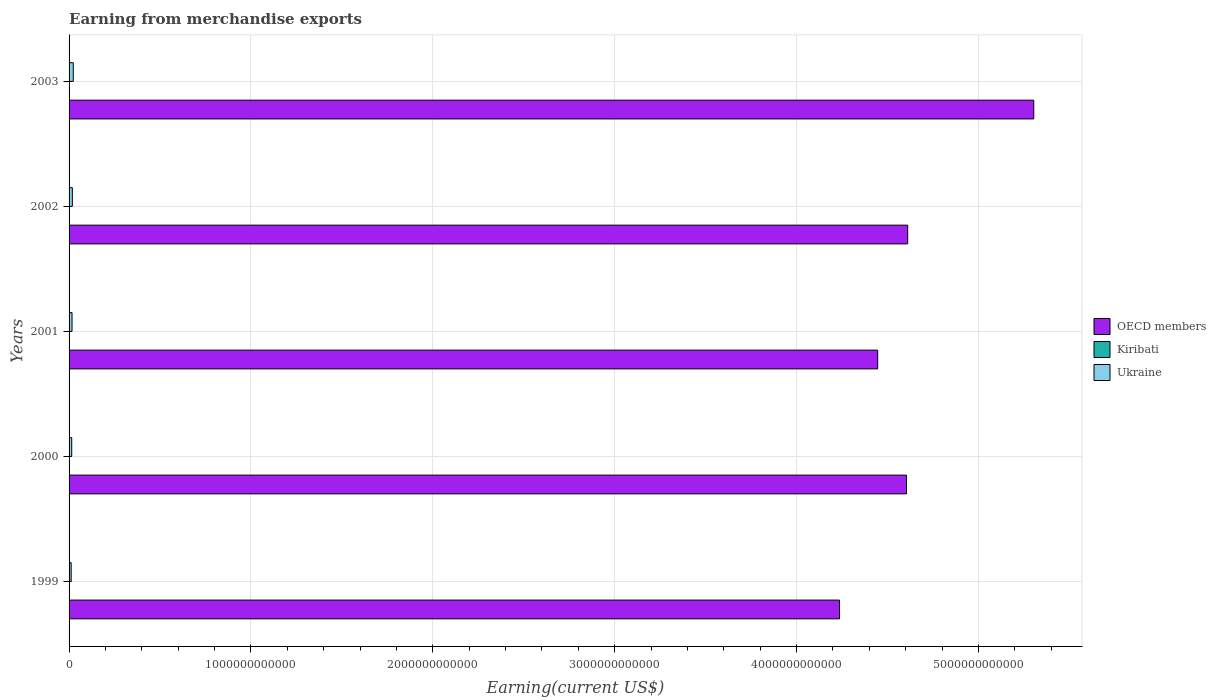How many different coloured bars are there?
Provide a short and direct response. 3. Are the number of bars per tick equal to the number of legend labels?
Give a very brief answer. Yes. How many bars are there on the 2nd tick from the top?
Offer a very short reply. 3. What is the amount earned from merchandise exports in Kiribati in 2002?
Your answer should be very brief. 3.44e+06. Across all years, what is the maximum amount earned from merchandise exports in Kiribati?
Provide a short and direct response. 8.76e+06. Across all years, what is the minimum amount earned from merchandise exports in Kiribati?
Your answer should be very brief. 2.90e+06. In which year was the amount earned from merchandise exports in OECD members maximum?
Ensure brevity in your answer.  2003. What is the total amount earned from merchandise exports in Ukraine in the graph?
Give a very brief answer. 8.34e+1. What is the difference between the amount earned from merchandise exports in Kiribati in 2000 and that in 2001?
Provide a short and direct response. -9.25e+05. What is the difference between the amount earned from merchandise exports in OECD members in 2001 and the amount earned from merchandise exports in Ukraine in 2002?
Your answer should be compact. 4.43e+12. What is the average amount earned from merchandise exports in Kiribati per year?
Offer a terse response. 4.64e+06. In the year 2001, what is the difference between the amount earned from merchandise exports in Kiribati and amount earned from merchandise exports in OECD members?
Offer a terse response. -4.45e+12. In how many years, is the amount earned from merchandise exports in Kiribati greater than 2800000000000 US$?
Your answer should be very brief. 0. What is the ratio of the amount earned from merchandise exports in OECD members in 1999 to that in 2002?
Provide a short and direct response. 0.92. Is the amount earned from merchandise exports in OECD members in 2000 less than that in 2002?
Offer a terse response. Yes. What is the difference between the highest and the second highest amount earned from merchandise exports in OECD members?
Ensure brevity in your answer.  6.93e+11. What is the difference between the highest and the lowest amount earned from merchandise exports in Kiribati?
Ensure brevity in your answer.  5.86e+06. What does the 1st bar from the bottom in 1999 represents?
Keep it short and to the point. OECD members. How many years are there in the graph?
Offer a very short reply. 5. What is the difference between two consecutive major ticks on the X-axis?
Offer a terse response. 1.00e+12. Are the values on the major ticks of X-axis written in scientific E-notation?
Make the answer very short. No. Does the graph contain any zero values?
Make the answer very short. No. What is the title of the graph?
Your answer should be very brief. Earning from merchandise exports. Does "Bolivia" appear as one of the legend labels in the graph?
Offer a terse response. No. What is the label or title of the X-axis?
Provide a succinct answer. Earning(current US$). What is the Earning(current US$) in OECD members in 1999?
Your answer should be compact. 4.24e+12. What is the Earning(current US$) of Kiribati in 1999?
Keep it short and to the point. 8.76e+06. What is the Earning(current US$) in Ukraine in 1999?
Your answer should be compact. 1.16e+1. What is the Earning(current US$) in OECD members in 2000?
Provide a succinct answer. 4.60e+12. What is the Earning(current US$) in Kiribati in 2000?
Offer a very short reply. 3.58e+06. What is the Earning(current US$) of Ukraine in 2000?
Ensure brevity in your answer.  1.46e+1. What is the Earning(current US$) of OECD members in 2001?
Make the answer very short. 4.45e+12. What is the Earning(current US$) in Kiribati in 2001?
Make the answer very short. 4.51e+06. What is the Earning(current US$) in Ukraine in 2001?
Your answer should be compact. 1.63e+1. What is the Earning(current US$) of OECD members in 2002?
Provide a short and direct response. 4.61e+12. What is the Earning(current US$) of Kiribati in 2002?
Your answer should be compact. 3.44e+06. What is the Earning(current US$) in Ukraine in 2002?
Provide a short and direct response. 1.80e+1. What is the Earning(current US$) of OECD members in 2003?
Ensure brevity in your answer.  5.30e+12. What is the Earning(current US$) of Kiribati in 2003?
Your answer should be very brief. 2.90e+06. What is the Earning(current US$) of Ukraine in 2003?
Offer a very short reply. 2.31e+1. Across all years, what is the maximum Earning(current US$) of OECD members?
Give a very brief answer. 5.30e+12. Across all years, what is the maximum Earning(current US$) in Kiribati?
Provide a short and direct response. 8.76e+06. Across all years, what is the maximum Earning(current US$) of Ukraine?
Offer a very short reply. 2.31e+1. Across all years, what is the minimum Earning(current US$) of OECD members?
Offer a terse response. 4.24e+12. Across all years, what is the minimum Earning(current US$) of Kiribati?
Your answer should be very brief. 2.90e+06. Across all years, what is the minimum Earning(current US$) in Ukraine?
Provide a succinct answer. 1.16e+1. What is the total Earning(current US$) of OECD members in the graph?
Your answer should be very brief. 2.32e+13. What is the total Earning(current US$) in Kiribati in the graph?
Ensure brevity in your answer.  2.32e+07. What is the total Earning(current US$) of Ukraine in the graph?
Provide a succinct answer. 8.34e+1. What is the difference between the Earning(current US$) of OECD members in 1999 and that in 2000?
Keep it short and to the point. -3.68e+11. What is the difference between the Earning(current US$) in Kiribati in 1999 and that in 2000?
Give a very brief answer. 5.17e+06. What is the difference between the Earning(current US$) of Ukraine in 1999 and that in 2000?
Provide a short and direct response. -2.99e+09. What is the difference between the Earning(current US$) of OECD members in 1999 and that in 2001?
Offer a terse response. -2.10e+11. What is the difference between the Earning(current US$) in Kiribati in 1999 and that in 2001?
Make the answer very short. 4.25e+06. What is the difference between the Earning(current US$) in Ukraine in 1999 and that in 2001?
Offer a very short reply. -4.68e+09. What is the difference between the Earning(current US$) of OECD members in 1999 and that in 2002?
Offer a very short reply. -3.75e+11. What is the difference between the Earning(current US$) of Kiribati in 1999 and that in 2002?
Your response must be concise. 5.32e+06. What is the difference between the Earning(current US$) of Ukraine in 1999 and that in 2002?
Give a very brief answer. -6.38e+09. What is the difference between the Earning(current US$) of OECD members in 1999 and that in 2003?
Offer a terse response. -1.07e+12. What is the difference between the Earning(current US$) in Kiribati in 1999 and that in 2003?
Provide a short and direct response. 5.86e+06. What is the difference between the Earning(current US$) of Ukraine in 1999 and that in 2003?
Ensure brevity in your answer.  -1.15e+1. What is the difference between the Earning(current US$) in OECD members in 2000 and that in 2001?
Your response must be concise. 1.58e+11. What is the difference between the Earning(current US$) in Kiribati in 2000 and that in 2001?
Your answer should be very brief. -9.25e+05. What is the difference between the Earning(current US$) of Ukraine in 2000 and that in 2001?
Provide a short and direct response. -1.69e+09. What is the difference between the Earning(current US$) of OECD members in 2000 and that in 2002?
Keep it short and to the point. -6.73e+09. What is the difference between the Earning(current US$) in Kiribati in 2000 and that in 2002?
Give a very brief answer. 1.47e+05. What is the difference between the Earning(current US$) of Ukraine in 2000 and that in 2002?
Your answer should be very brief. -3.38e+09. What is the difference between the Earning(current US$) of OECD members in 2000 and that in 2003?
Your answer should be very brief. -7.00e+11. What is the difference between the Earning(current US$) of Kiribati in 2000 and that in 2003?
Keep it short and to the point. 6.83e+05. What is the difference between the Earning(current US$) of Ukraine in 2000 and that in 2003?
Ensure brevity in your answer.  -8.49e+09. What is the difference between the Earning(current US$) in OECD members in 2001 and that in 2002?
Ensure brevity in your answer.  -1.65e+11. What is the difference between the Earning(current US$) in Kiribati in 2001 and that in 2002?
Keep it short and to the point. 1.07e+06. What is the difference between the Earning(current US$) in Ukraine in 2001 and that in 2002?
Keep it short and to the point. -1.69e+09. What is the difference between the Earning(current US$) of OECD members in 2001 and that in 2003?
Keep it short and to the point. -8.58e+11. What is the difference between the Earning(current US$) in Kiribati in 2001 and that in 2003?
Provide a short and direct response. 1.61e+06. What is the difference between the Earning(current US$) in Ukraine in 2001 and that in 2003?
Offer a very short reply. -6.80e+09. What is the difference between the Earning(current US$) of OECD members in 2002 and that in 2003?
Your response must be concise. -6.93e+11. What is the difference between the Earning(current US$) in Kiribati in 2002 and that in 2003?
Provide a short and direct response. 5.36e+05. What is the difference between the Earning(current US$) in Ukraine in 2002 and that in 2003?
Give a very brief answer. -5.11e+09. What is the difference between the Earning(current US$) in OECD members in 1999 and the Earning(current US$) in Kiribati in 2000?
Give a very brief answer. 4.24e+12. What is the difference between the Earning(current US$) of OECD members in 1999 and the Earning(current US$) of Ukraine in 2000?
Your answer should be very brief. 4.22e+12. What is the difference between the Earning(current US$) of Kiribati in 1999 and the Earning(current US$) of Ukraine in 2000?
Offer a very short reply. -1.46e+1. What is the difference between the Earning(current US$) of OECD members in 1999 and the Earning(current US$) of Kiribati in 2001?
Your answer should be compact. 4.24e+12. What is the difference between the Earning(current US$) in OECD members in 1999 and the Earning(current US$) in Ukraine in 2001?
Give a very brief answer. 4.22e+12. What is the difference between the Earning(current US$) of Kiribati in 1999 and the Earning(current US$) of Ukraine in 2001?
Offer a terse response. -1.63e+1. What is the difference between the Earning(current US$) in OECD members in 1999 and the Earning(current US$) in Kiribati in 2002?
Give a very brief answer. 4.24e+12. What is the difference between the Earning(current US$) in OECD members in 1999 and the Earning(current US$) in Ukraine in 2002?
Ensure brevity in your answer.  4.22e+12. What is the difference between the Earning(current US$) of Kiribati in 1999 and the Earning(current US$) of Ukraine in 2002?
Give a very brief answer. -1.79e+1. What is the difference between the Earning(current US$) of OECD members in 1999 and the Earning(current US$) of Kiribati in 2003?
Give a very brief answer. 4.24e+12. What is the difference between the Earning(current US$) in OECD members in 1999 and the Earning(current US$) in Ukraine in 2003?
Offer a terse response. 4.21e+12. What is the difference between the Earning(current US$) of Kiribati in 1999 and the Earning(current US$) of Ukraine in 2003?
Offer a terse response. -2.31e+1. What is the difference between the Earning(current US$) in OECD members in 2000 and the Earning(current US$) in Kiribati in 2001?
Ensure brevity in your answer.  4.60e+12. What is the difference between the Earning(current US$) in OECD members in 2000 and the Earning(current US$) in Ukraine in 2001?
Ensure brevity in your answer.  4.59e+12. What is the difference between the Earning(current US$) of Kiribati in 2000 and the Earning(current US$) of Ukraine in 2001?
Provide a short and direct response. -1.63e+1. What is the difference between the Earning(current US$) of OECD members in 2000 and the Earning(current US$) of Kiribati in 2002?
Offer a terse response. 4.60e+12. What is the difference between the Earning(current US$) of OECD members in 2000 and the Earning(current US$) of Ukraine in 2002?
Keep it short and to the point. 4.59e+12. What is the difference between the Earning(current US$) of Kiribati in 2000 and the Earning(current US$) of Ukraine in 2002?
Provide a succinct answer. -1.80e+1. What is the difference between the Earning(current US$) of OECD members in 2000 and the Earning(current US$) of Kiribati in 2003?
Your response must be concise. 4.60e+12. What is the difference between the Earning(current US$) in OECD members in 2000 and the Earning(current US$) in Ukraine in 2003?
Provide a succinct answer. 4.58e+12. What is the difference between the Earning(current US$) in Kiribati in 2000 and the Earning(current US$) in Ukraine in 2003?
Give a very brief answer. -2.31e+1. What is the difference between the Earning(current US$) of OECD members in 2001 and the Earning(current US$) of Kiribati in 2002?
Your answer should be very brief. 4.45e+12. What is the difference between the Earning(current US$) of OECD members in 2001 and the Earning(current US$) of Ukraine in 2002?
Your answer should be compact. 4.43e+12. What is the difference between the Earning(current US$) in Kiribati in 2001 and the Earning(current US$) in Ukraine in 2002?
Make the answer very short. -1.80e+1. What is the difference between the Earning(current US$) in OECD members in 2001 and the Earning(current US$) in Kiribati in 2003?
Ensure brevity in your answer.  4.45e+12. What is the difference between the Earning(current US$) of OECD members in 2001 and the Earning(current US$) of Ukraine in 2003?
Ensure brevity in your answer.  4.42e+12. What is the difference between the Earning(current US$) in Kiribati in 2001 and the Earning(current US$) in Ukraine in 2003?
Your answer should be compact. -2.31e+1. What is the difference between the Earning(current US$) in OECD members in 2002 and the Earning(current US$) in Kiribati in 2003?
Provide a short and direct response. 4.61e+12. What is the difference between the Earning(current US$) of OECD members in 2002 and the Earning(current US$) of Ukraine in 2003?
Offer a very short reply. 4.59e+12. What is the difference between the Earning(current US$) in Kiribati in 2002 and the Earning(current US$) in Ukraine in 2003?
Ensure brevity in your answer.  -2.31e+1. What is the average Earning(current US$) in OECD members per year?
Make the answer very short. 4.64e+12. What is the average Earning(current US$) in Kiribati per year?
Your answer should be very brief. 4.64e+06. What is the average Earning(current US$) of Ukraine per year?
Keep it short and to the point. 1.67e+1. In the year 1999, what is the difference between the Earning(current US$) in OECD members and Earning(current US$) in Kiribati?
Give a very brief answer. 4.24e+12. In the year 1999, what is the difference between the Earning(current US$) of OECD members and Earning(current US$) of Ukraine?
Provide a succinct answer. 4.22e+12. In the year 1999, what is the difference between the Earning(current US$) in Kiribati and Earning(current US$) in Ukraine?
Ensure brevity in your answer.  -1.16e+1. In the year 2000, what is the difference between the Earning(current US$) of OECD members and Earning(current US$) of Kiribati?
Provide a short and direct response. 4.60e+12. In the year 2000, what is the difference between the Earning(current US$) in OECD members and Earning(current US$) in Ukraine?
Your answer should be compact. 4.59e+12. In the year 2000, what is the difference between the Earning(current US$) of Kiribati and Earning(current US$) of Ukraine?
Keep it short and to the point. -1.46e+1. In the year 2001, what is the difference between the Earning(current US$) in OECD members and Earning(current US$) in Kiribati?
Your answer should be compact. 4.45e+12. In the year 2001, what is the difference between the Earning(current US$) of OECD members and Earning(current US$) of Ukraine?
Provide a succinct answer. 4.43e+12. In the year 2001, what is the difference between the Earning(current US$) of Kiribati and Earning(current US$) of Ukraine?
Offer a very short reply. -1.63e+1. In the year 2002, what is the difference between the Earning(current US$) of OECD members and Earning(current US$) of Kiribati?
Give a very brief answer. 4.61e+12. In the year 2002, what is the difference between the Earning(current US$) of OECD members and Earning(current US$) of Ukraine?
Keep it short and to the point. 4.59e+12. In the year 2002, what is the difference between the Earning(current US$) of Kiribati and Earning(current US$) of Ukraine?
Give a very brief answer. -1.80e+1. In the year 2003, what is the difference between the Earning(current US$) of OECD members and Earning(current US$) of Kiribati?
Provide a succinct answer. 5.30e+12. In the year 2003, what is the difference between the Earning(current US$) in OECD members and Earning(current US$) in Ukraine?
Your answer should be compact. 5.28e+12. In the year 2003, what is the difference between the Earning(current US$) in Kiribati and Earning(current US$) in Ukraine?
Provide a succinct answer. -2.31e+1. What is the ratio of the Earning(current US$) in Kiribati in 1999 to that in 2000?
Offer a terse response. 2.44. What is the ratio of the Earning(current US$) of Ukraine in 1999 to that in 2000?
Make the answer very short. 0.79. What is the ratio of the Earning(current US$) in OECD members in 1999 to that in 2001?
Provide a short and direct response. 0.95. What is the ratio of the Earning(current US$) in Kiribati in 1999 to that in 2001?
Ensure brevity in your answer.  1.94. What is the ratio of the Earning(current US$) of Ukraine in 1999 to that in 2001?
Provide a short and direct response. 0.71. What is the ratio of the Earning(current US$) in OECD members in 1999 to that in 2002?
Give a very brief answer. 0.92. What is the ratio of the Earning(current US$) of Kiribati in 1999 to that in 2002?
Your answer should be very brief. 2.55. What is the ratio of the Earning(current US$) of Ukraine in 1999 to that in 2002?
Make the answer very short. 0.65. What is the ratio of the Earning(current US$) of OECD members in 1999 to that in 2003?
Ensure brevity in your answer.  0.8. What is the ratio of the Earning(current US$) in Kiribati in 1999 to that in 2003?
Keep it short and to the point. 3.02. What is the ratio of the Earning(current US$) of Ukraine in 1999 to that in 2003?
Provide a succinct answer. 0.5. What is the ratio of the Earning(current US$) in OECD members in 2000 to that in 2001?
Provide a succinct answer. 1.04. What is the ratio of the Earning(current US$) of Kiribati in 2000 to that in 2001?
Your answer should be very brief. 0.79. What is the ratio of the Earning(current US$) in Ukraine in 2000 to that in 2001?
Provide a short and direct response. 0.9. What is the ratio of the Earning(current US$) of OECD members in 2000 to that in 2002?
Give a very brief answer. 1. What is the ratio of the Earning(current US$) in Kiribati in 2000 to that in 2002?
Your answer should be very brief. 1.04. What is the ratio of the Earning(current US$) of Ukraine in 2000 to that in 2002?
Keep it short and to the point. 0.81. What is the ratio of the Earning(current US$) in OECD members in 2000 to that in 2003?
Keep it short and to the point. 0.87. What is the ratio of the Earning(current US$) of Kiribati in 2000 to that in 2003?
Ensure brevity in your answer.  1.24. What is the ratio of the Earning(current US$) of Ukraine in 2000 to that in 2003?
Keep it short and to the point. 0.63. What is the ratio of the Earning(current US$) of OECD members in 2001 to that in 2002?
Your response must be concise. 0.96. What is the ratio of the Earning(current US$) in Kiribati in 2001 to that in 2002?
Offer a very short reply. 1.31. What is the ratio of the Earning(current US$) of Ukraine in 2001 to that in 2002?
Your answer should be very brief. 0.91. What is the ratio of the Earning(current US$) of OECD members in 2001 to that in 2003?
Make the answer very short. 0.84. What is the ratio of the Earning(current US$) of Kiribati in 2001 to that in 2003?
Provide a short and direct response. 1.55. What is the ratio of the Earning(current US$) of Ukraine in 2001 to that in 2003?
Offer a terse response. 0.71. What is the ratio of the Earning(current US$) in OECD members in 2002 to that in 2003?
Offer a terse response. 0.87. What is the ratio of the Earning(current US$) in Kiribati in 2002 to that in 2003?
Your answer should be very brief. 1.18. What is the ratio of the Earning(current US$) in Ukraine in 2002 to that in 2003?
Give a very brief answer. 0.78. What is the difference between the highest and the second highest Earning(current US$) in OECD members?
Give a very brief answer. 6.93e+11. What is the difference between the highest and the second highest Earning(current US$) in Kiribati?
Ensure brevity in your answer.  4.25e+06. What is the difference between the highest and the second highest Earning(current US$) in Ukraine?
Provide a short and direct response. 5.11e+09. What is the difference between the highest and the lowest Earning(current US$) of OECD members?
Provide a short and direct response. 1.07e+12. What is the difference between the highest and the lowest Earning(current US$) of Kiribati?
Provide a succinct answer. 5.86e+06. What is the difference between the highest and the lowest Earning(current US$) of Ukraine?
Keep it short and to the point. 1.15e+1. 